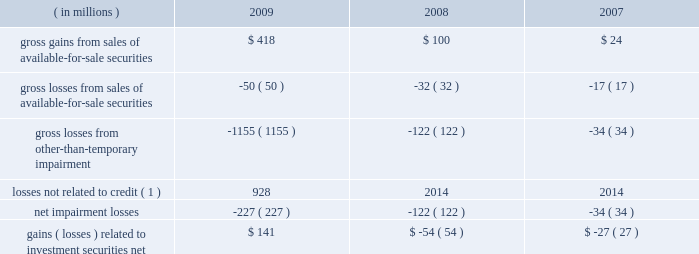In connection with our assessment of impairment we recorded gross other-than-temporary impairment of $ 1.15 billion for 2009 , compared to $ 122 million for 2008 .
Of the total recorded , $ 227 million related to credit and was recognized in our consolidated statement of income .
The remaining $ 928 million related to factors other than credit , more fully discussed below , and was recognized , net of related taxes , in oci in our consolidated statement of condition .
The $ 227 million was composed of $ 151 million associated with expected credit losses , $ 54 million related to management 2019s decision to sell the impaired securities prior to their recovery in value , and $ 22 million related to adverse changes in the timing of expected future cash flows from the securities .
The majority of the impairment losses related to non-agency securities collateralized by mortgages , for which management concluded had experienced credit losses based on the present value of the securities 2019 expected future cash flows .
These securities are classified as asset-backed securities in the foregoing investment securities tables .
As described in note 1 , management periodically reviews the fair values of investment securities to determine if other-than-temporary impairment has occurred .
This review encompasses all investment securities and includes such quantitative factors as current and expected future interest rates and the length of time that a security 2019s cost basis has exceeded its fair value , and includes investment securities for which we have issuer- specific concerns regardless of quantitative factors .
Gains and losses related to investment securities were as follows for the years ended december 31: .
( 1 ) these losses were recognized as a component of oci ; see note 12 .
We conduct periodic reviews to evaluate each security that is impaired .
Impairment exists when the current fair value of an individual security is below its amortized cost basis .
For debt securities available for sale and held to maturity , other-than-temporary impairment is recorded in our consolidated statement of income when management intends to sell ( or may be required to sell ) securities before they recover in value , or when management expects the present value of cash flows expected to be collected to be less than the amortized cost of the impaired security ( a credit loss ) .
Our review of impaired securities generally includes : 2022 the identification and evaluation of securities that have indications of possible other-than-temporary impairment , such as issuer-specific concerns including deteriorating financial condition or bankruptcy ; 2022 the analysis of expected future cash flows of securities , based on quantitative and qualitative factors ; 2022 the analysis of the collectability of those future cash flows , including information about past events , current conditions and reasonable and supportable forecasts ; 2022 the analysis of individual impaired securities , including consideration of the length of time the security has been in an unrealized loss position and the anticipated recovery period ; 2022 the discussion of evidential matter , including an evaluation of factors or triggers that could cause individual securities to be deemed other-than-temporarily impaired and those that would not support other-than-temporary impairment ; and 2022 documentation of the results of these analyses .
Factors considered in determining whether impairment is other than temporary include : 2022 the length of time the security has been impaired; .
What was the percent change in gross gains from sales of available-for-sale securities between 2008 and 2009? 
Computations: ((418 - 100) / 100)
Answer: 3.18. In connection with our assessment of impairment we recorded gross other-than-temporary impairment of $ 1.15 billion for 2009 , compared to $ 122 million for 2008 .
Of the total recorded , $ 227 million related to credit and was recognized in our consolidated statement of income .
The remaining $ 928 million related to factors other than credit , more fully discussed below , and was recognized , net of related taxes , in oci in our consolidated statement of condition .
The $ 227 million was composed of $ 151 million associated with expected credit losses , $ 54 million related to management 2019s decision to sell the impaired securities prior to their recovery in value , and $ 22 million related to adverse changes in the timing of expected future cash flows from the securities .
The majority of the impairment losses related to non-agency securities collateralized by mortgages , for which management concluded had experienced credit losses based on the present value of the securities 2019 expected future cash flows .
These securities are classified as asset-backed securities in the foregoing investment securities tables .
As described in note 1 , management periodically reviews the fair values of investment securities to determine if other-than-temporary impairment has occurred .
This review encompasses all investment securities and includes such quantitative factors as current and expected future interest rates and the length of time that a security 2019s cost basis has exceeded its fair value , and includes investment securities for which we have issuer- specific concerns regardless of quantitative factors .
Gains and losses related to investment securities were as follows for the years ended december 31: .
( 1 ) these losses were recognized as a component of oci ; see note 12 .
We conduct periodic reviews to evaluate each security that is impaired .
Impairment exists when the current fair value of an individual security is below its amortized cost basis .
For debt securities available for sale and held to maturity , other-than-temporary impairment is recorded in our consolidated statement of income when management intends to sell ( or may be required to sell ) securities before they recover in value , or when management expects the present value of cash flows expected to be collected to be less than the amortized cost of the impaired security ( a credit loss ) .
Our review of impaired securities generally includes : 2022 the identification and evaluation of securities that have indications of possible other-than-temporary impairment , such as issuer-specific concerns including deteriorating financial condition or bankruptcy ; 2022 the analysis of expected future cash flows of securities , based on quantitative and qualitative factors ; 2022 the analysis of the collectability of those future cash flows , including information about past events , current conditions and reasonable and supportable forecasts ; 2022 the analysis of individual impaired securities , including consideration of the length of time the security has been in an unrealized loss position and the anticipated recovery period ; 2022 the discussion of evidential matter , including an evaluation of factors or triggers that could cause individual securities to be deemed other-than-temporarily impaired and those that would not support other-than-temporary impairment ; and 2022 documentation of the results of these analyses .
Factors considered in determining whether impairment is other than temporary include : 2022 the length of time the security has been impaired; .
What percent of the $ 227 million was associated with expected credit losses? 
Computations: (151 / 227)
Answer: 0.6652. 